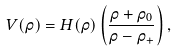Convert formula to latex. <formula><loc_0><loc_0><loc_500><loc_500>V ( \rho ) = H ( \rho ) \left ( \frac { \rho + \rho _ { 0 } } { \rho - \rho _ { + } } \right ) ,</formula> 